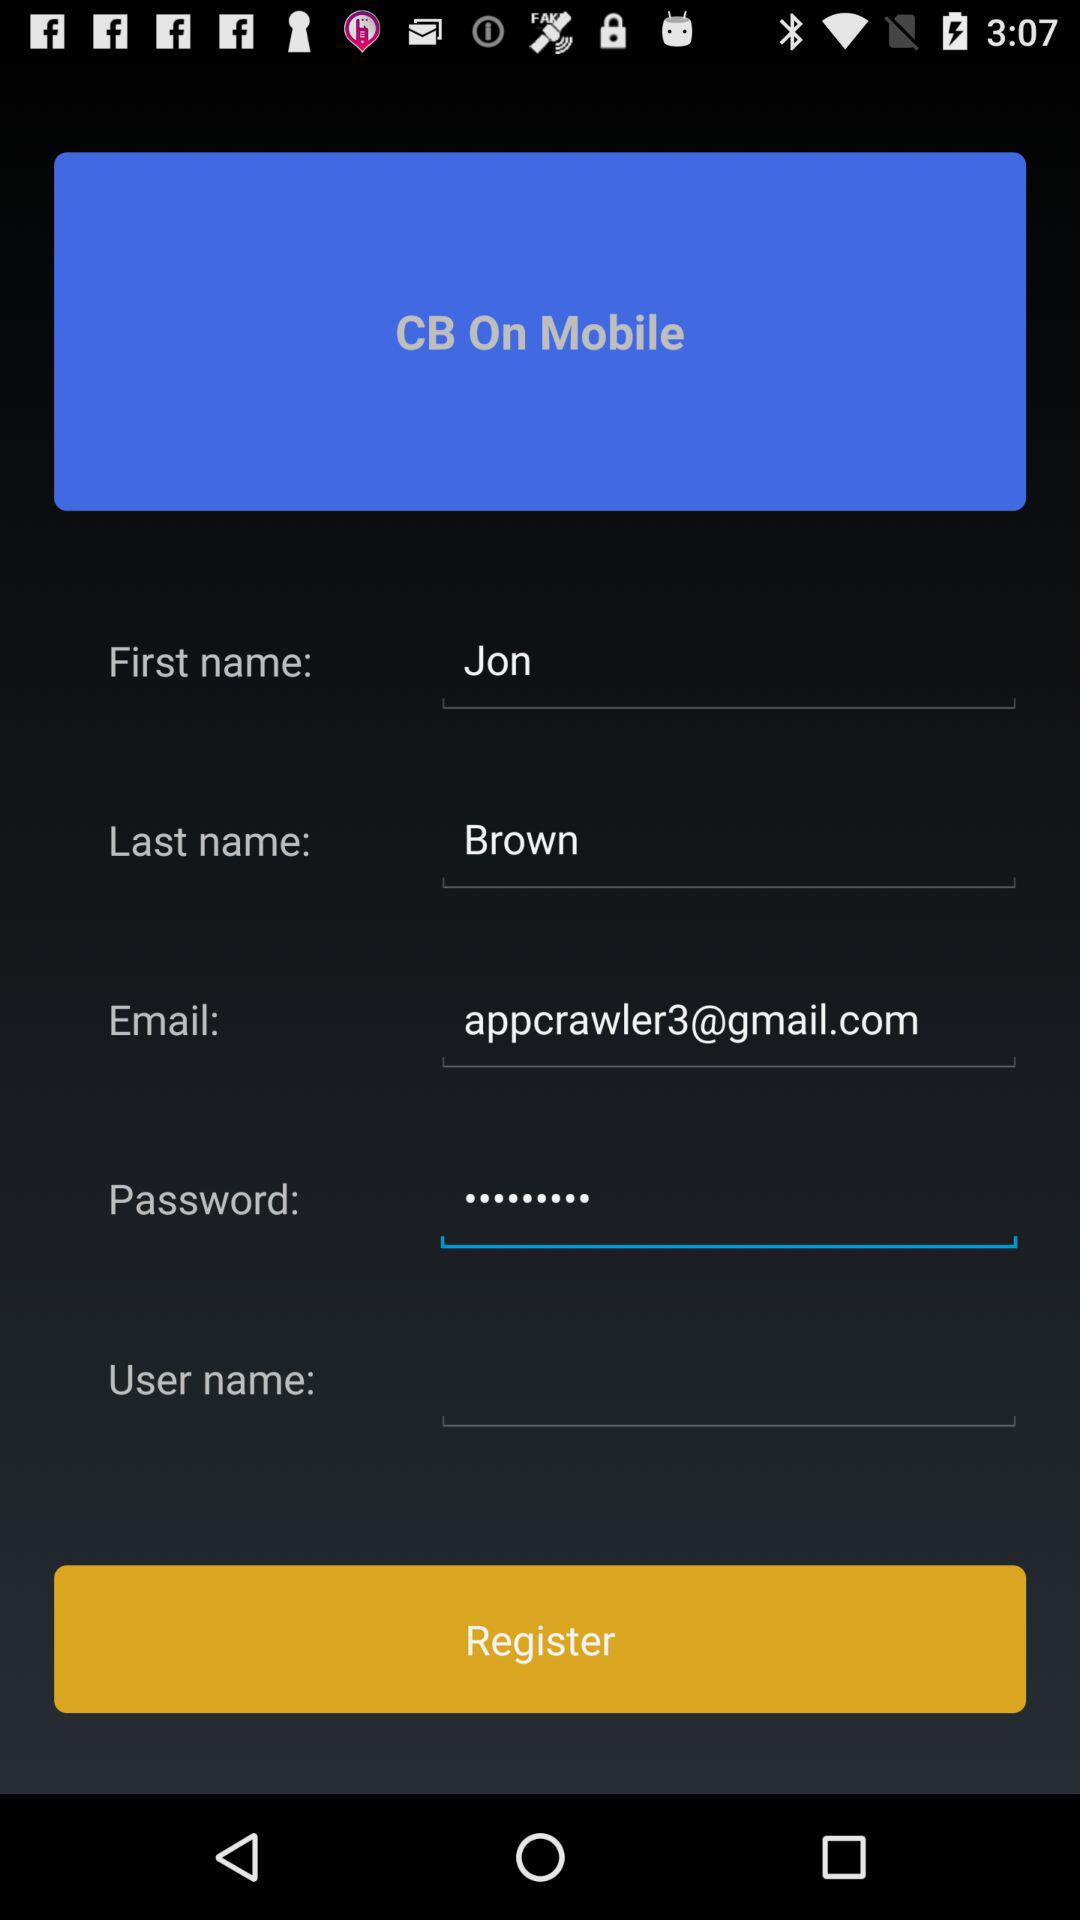What is the first name? The first name is Jon. 